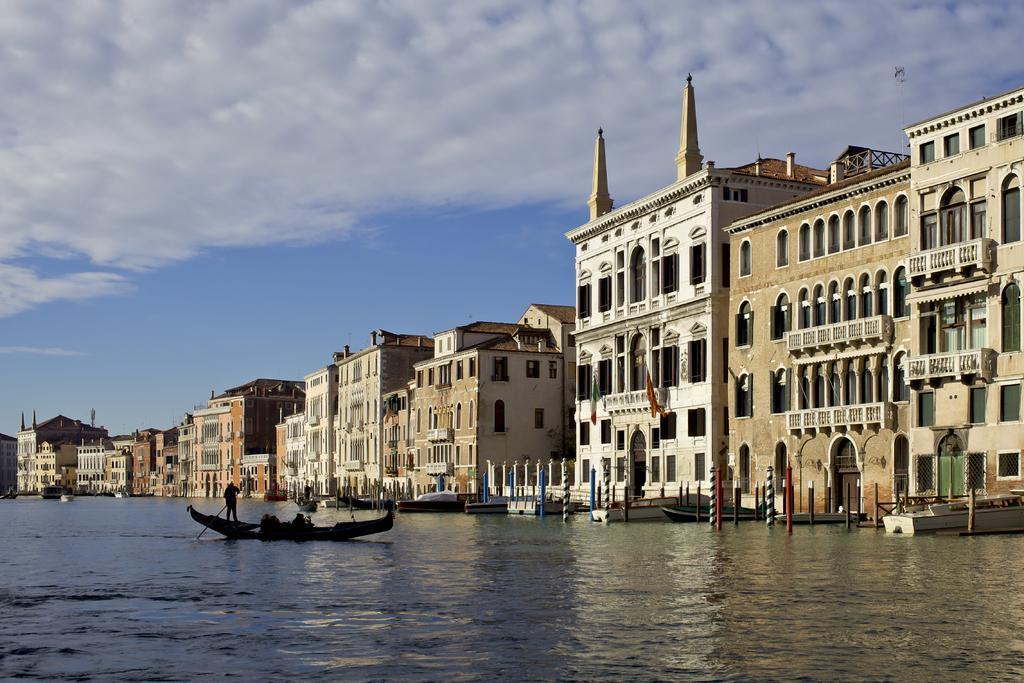What is the main subject in the foreground of the image? There is a boat in the foreground of the image. Who is on the boat? A man is standing on the boat. What is the boat's location? The boat is on the water. What can be seen in the background of the image? There are buildings and poles in the background of the image. What is visible at the top of the image? The sky is visible at the top of the image. What type of suit is the servant wearing in the image? There is no servant or suit present in the image. What system is being used to power the boat in the image? The image does not provide information about the boat's power source, so it cannot be determined from the image. 